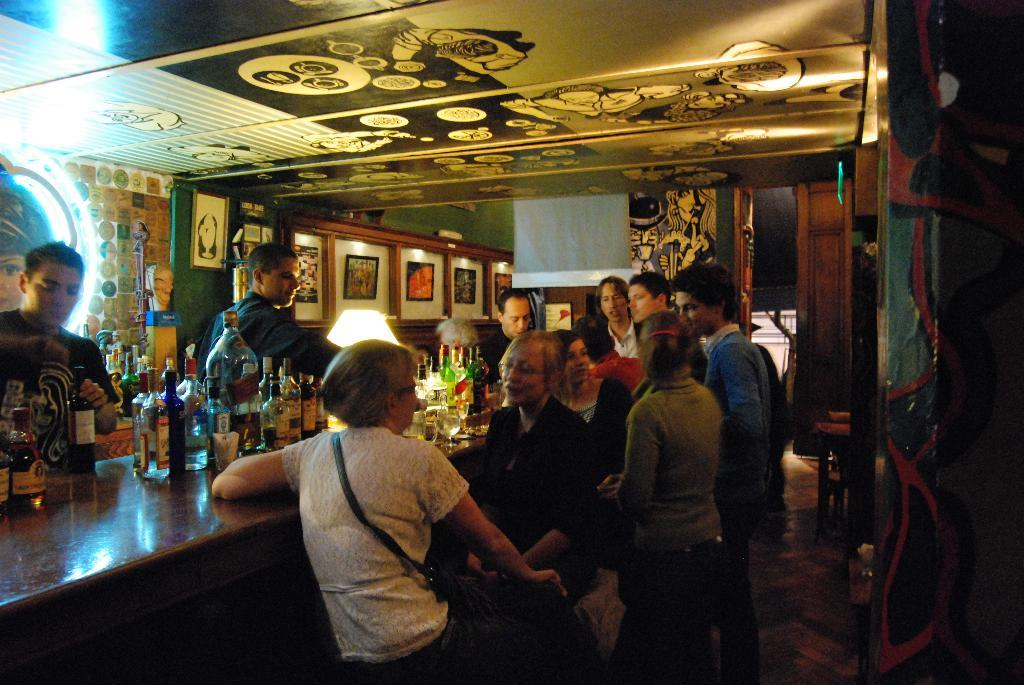How many people are in the image? There are people in the image, but the exact number is not specified. What are some of the people doing in the image? Some people are standing, and some people are sitting. What objects can be seen in the image besides people? There are bottles visible in the image, and there are frames on the walls. What type of coat is being argued about in the image? There is no mention of a coat or an argument in the image. The image features people standing and sitting, as well as bottles and frames on the walls. 